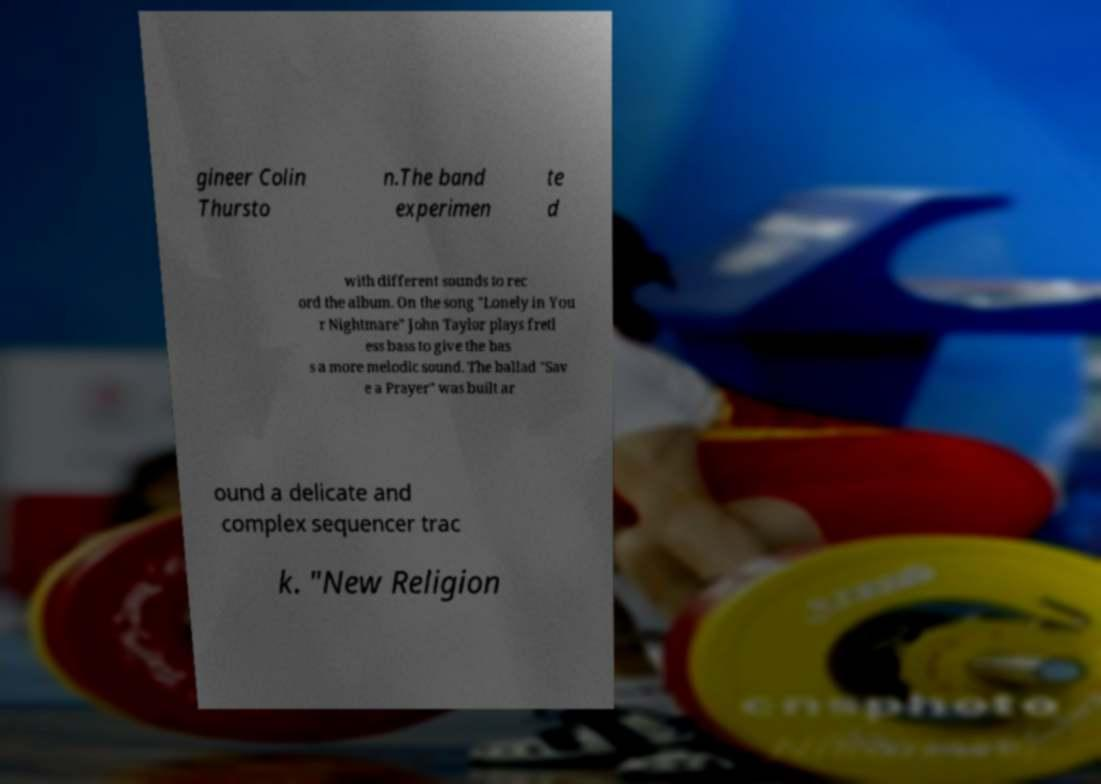Please read and relay the text visible in this image. What does it say? gineer Colin Thursto n.The band experimen te d with different sounds to rec ord the album. On the song "Lonely in You r Nightmare" John Taylor plays fretl ess bass to give the bas s a more melodic sound. The ballad "Sav e a Prayer" was built ar ound a delicate and complex sequencer trac k. "New Religion 